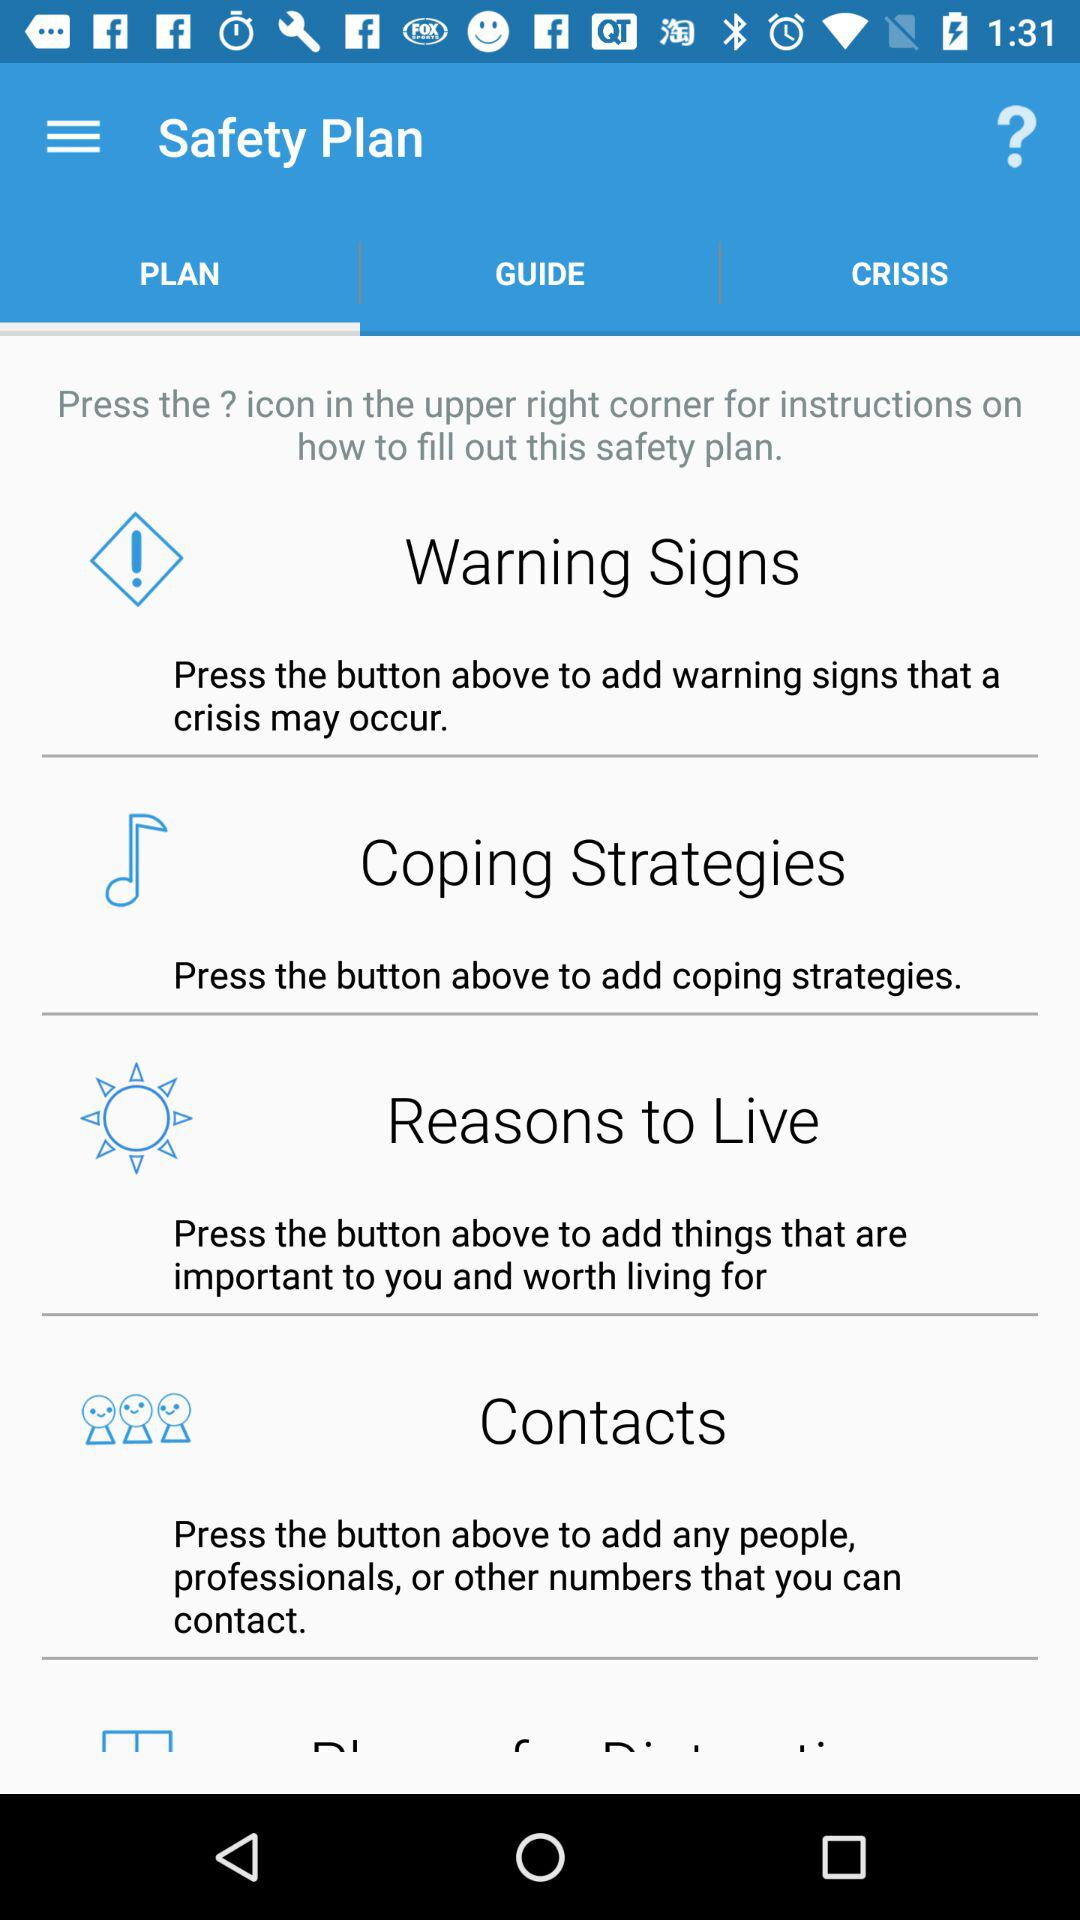What is the app name? The app name is "Safety Plan". 